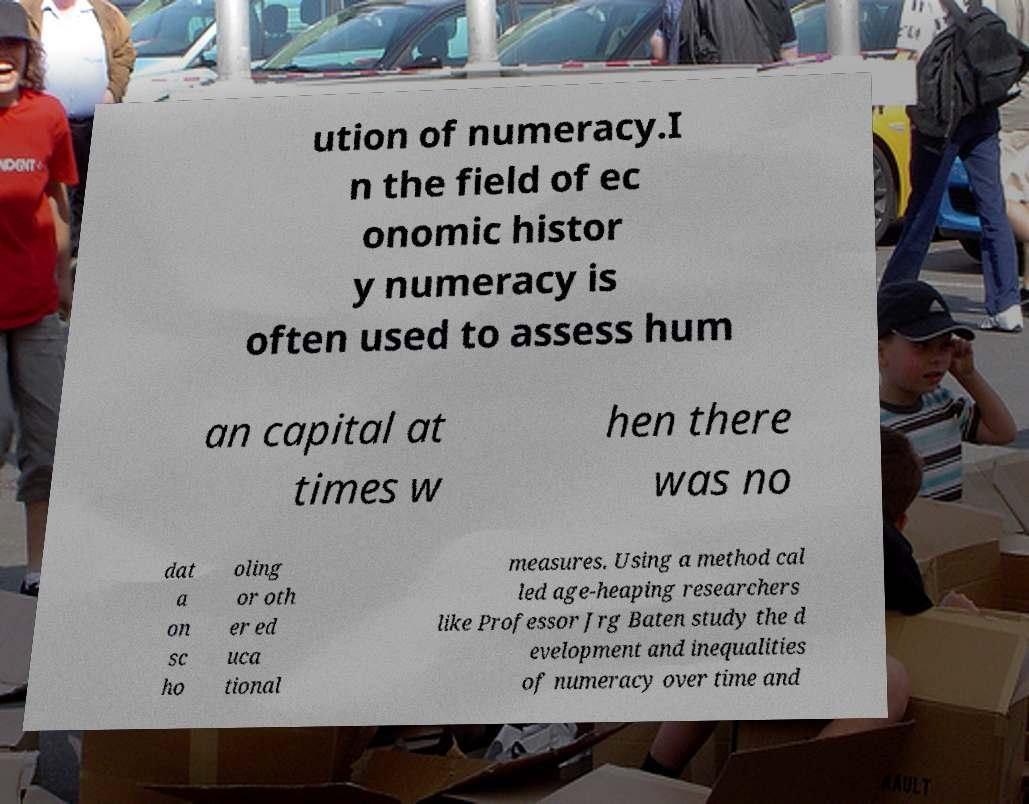Could you extract and type out the text from this image? ution of numeracy.I n the field of ec onomic histor y numeracy is often used to assess hum an capital at times w hen there was no dat a on sc ho oling or oth er ed uca tional measures. Using a method cal led age-heaping researchers like Professor Jrg Baten study the d evelopment and inequalities of numeracy over time and 